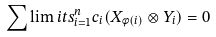Convert formula to latex. <formula><loc_0><loc_0><loc_500><loc_500>\sum \lim i t s _ { i = 1 } ^ { n } c _ { i } ( X _ { \phi ( i ) } \otimes Y _ { i } ) = 0</formula> 